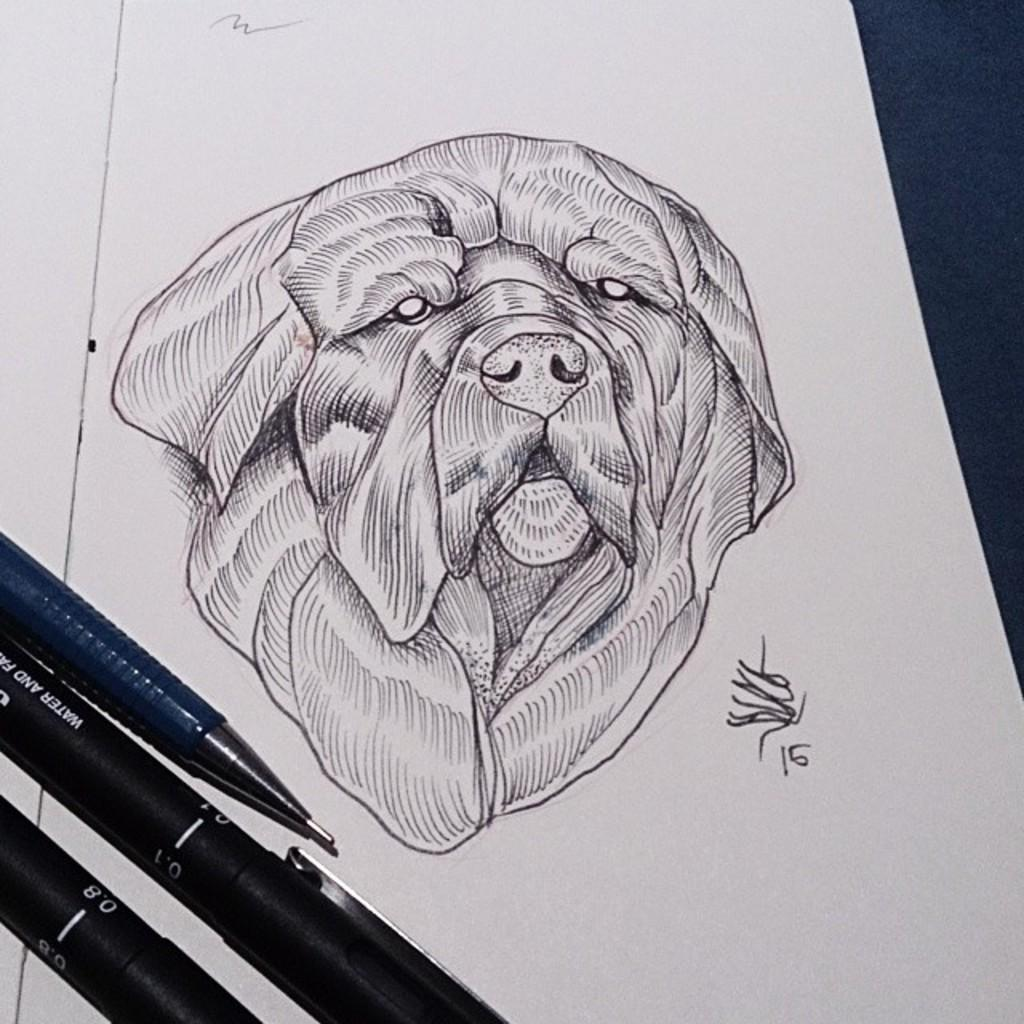What is depicted on the paper in the image? There is a drawing of a dog on the paper. What objects are present in the image that might be used for drawing? There are pens in the image. What type of hook can be seen hanging from the dog's collar in the image? There is no hook or collar present on the dog in the image, as it is a drawing on paper. Can you tell me where the nearest hospital is in relation to the image? There is no information about the location or surroundings of the image, so it is not possible to determine the nearest hospital. 